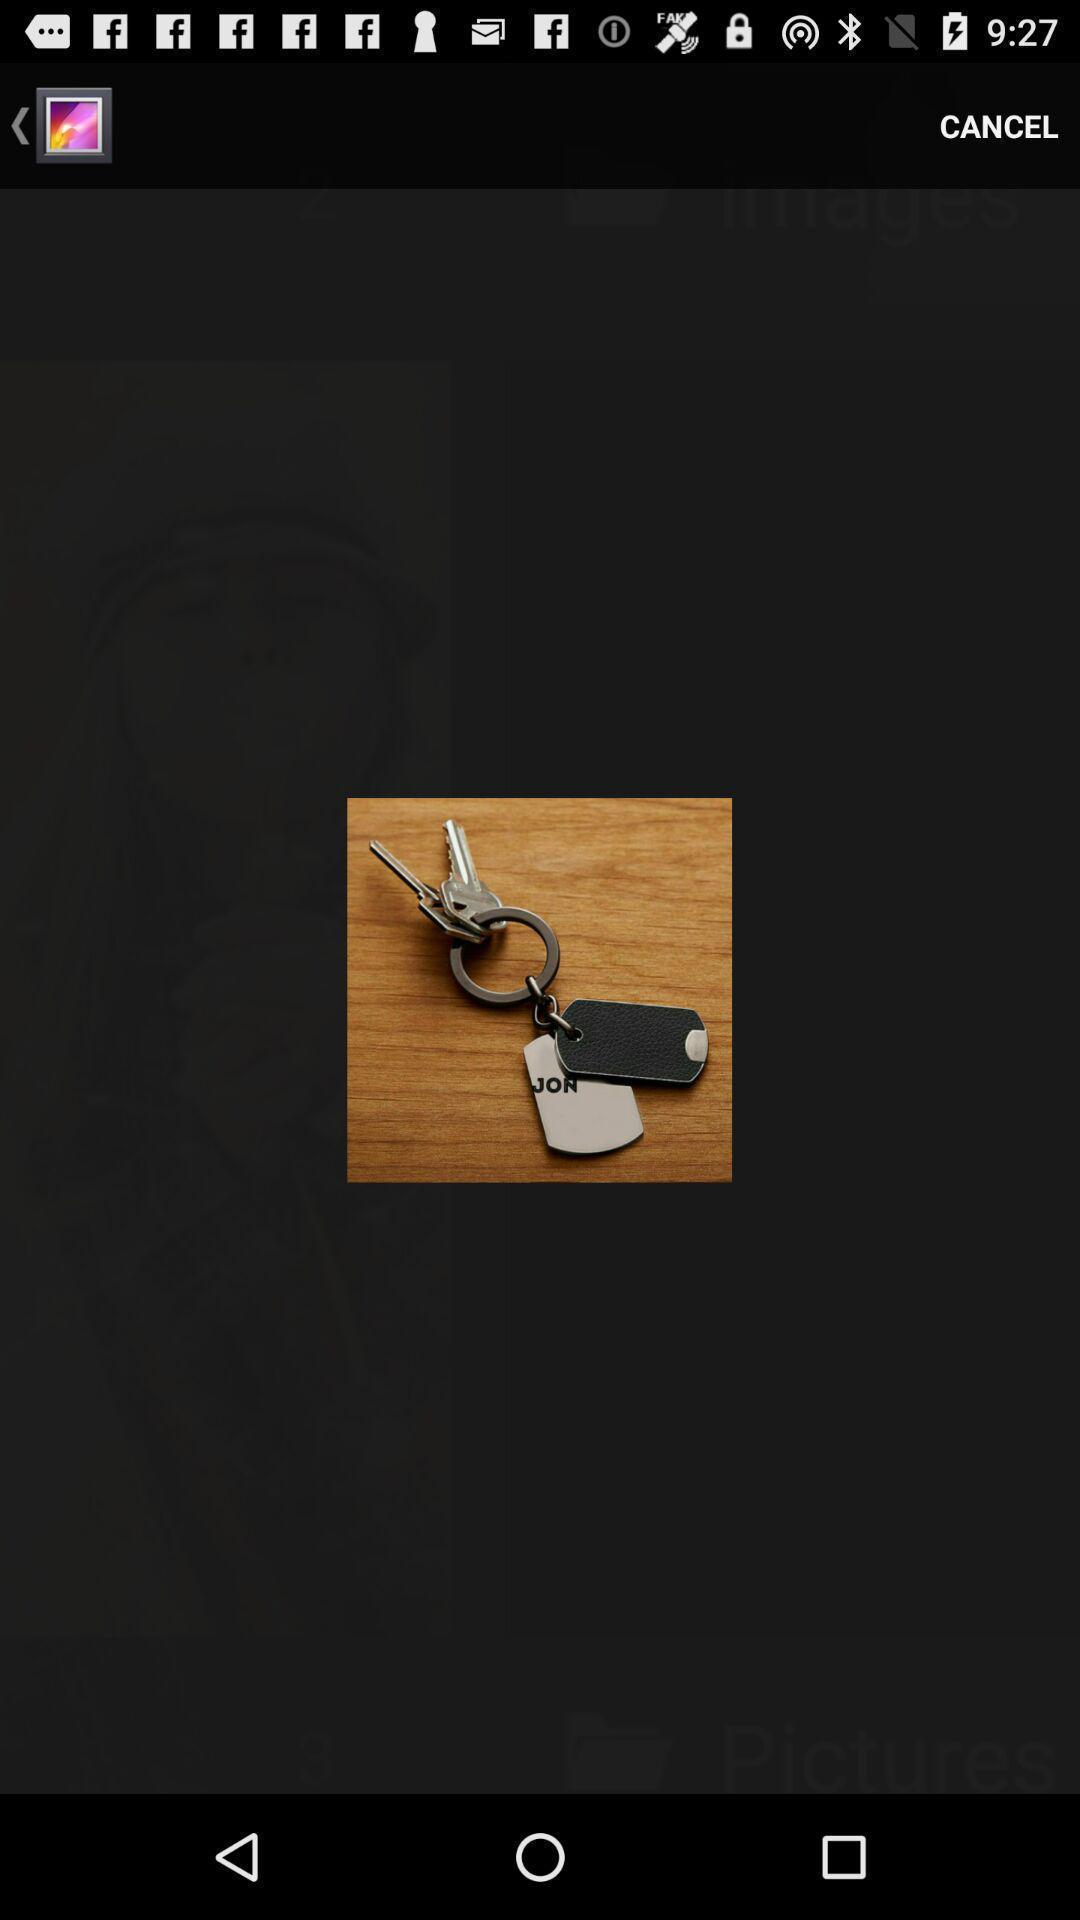Provide a description of this screenshot. Screen shows an image in gallery. 